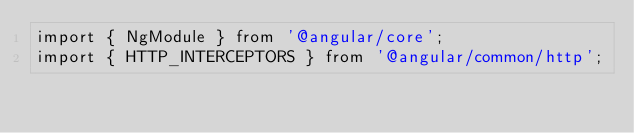<code> <loc_0><loc_0><loc_500><loc_500><_TypeScript_>import { NgModule } from '@angular/core';
import { HTTP_INTERCEPTORS } from '@angular/common/http';</code> 